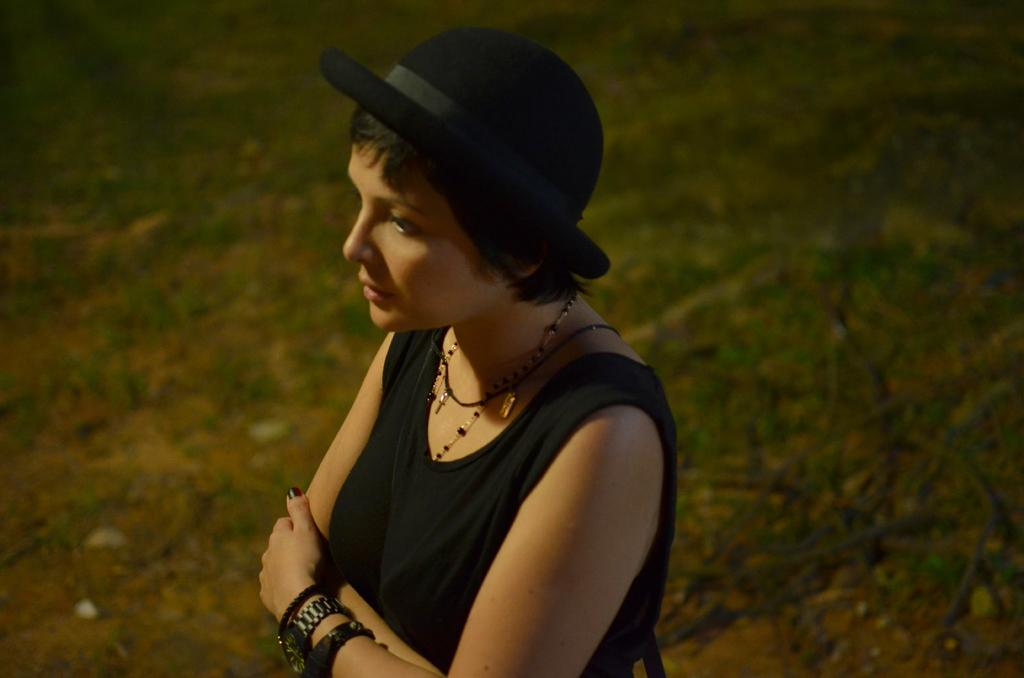Who is the main subject in the image? There is a woman in the image. What is the woman wearing on her upper body? The woman is wearing a black tank top. What is the woman wearing on her head? The woman is wearing a black hat. Where is the woman standing in the image? The woman is standing on a grass path. Can you describe the kitty playing with the woman's hat in the image? There is no kitty present in the image, and the woman's hat is not being played with. 